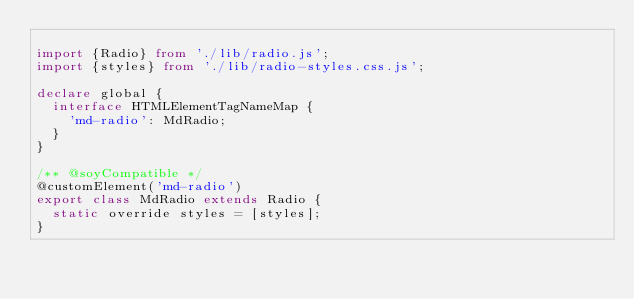Convert code to text. <code><loc_0><loc_0><loc_500><loc_500><_TypeScript_>
import {Radio} from './lib/radio.js';
import {styles} from './lib/radio-styles.css.js';

declare global {
  interface HTMLElementTagNameMap {
    'md-radio': MdRadio;
  }
}

/** @soyCompatible */
@customElement('md-radio')
export class MdRadio extends Radio {
  static override styles = [styles];
}
</code> 